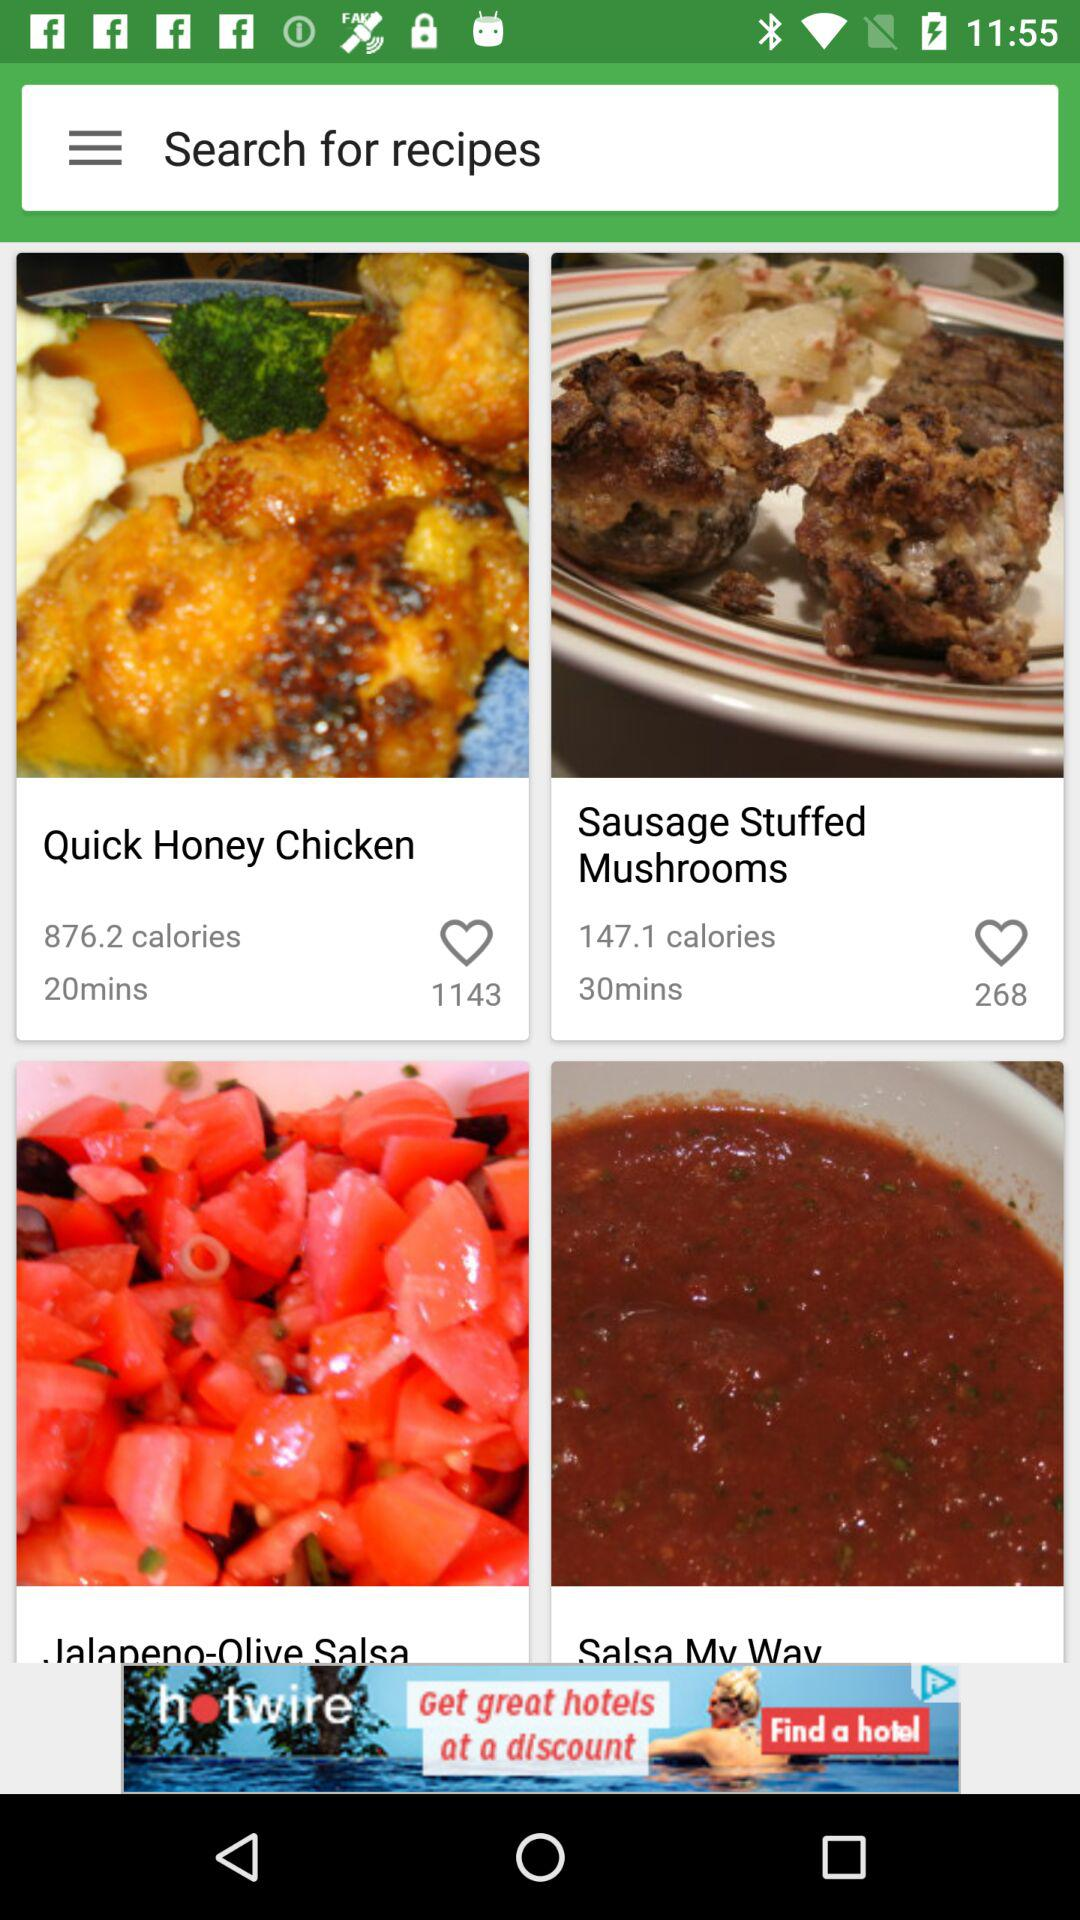How many more minutes are required to make the Sausage Stuffed Mushrooms than the Quick Honey Chicken?
Answer the question using a single word or phrase. 10 